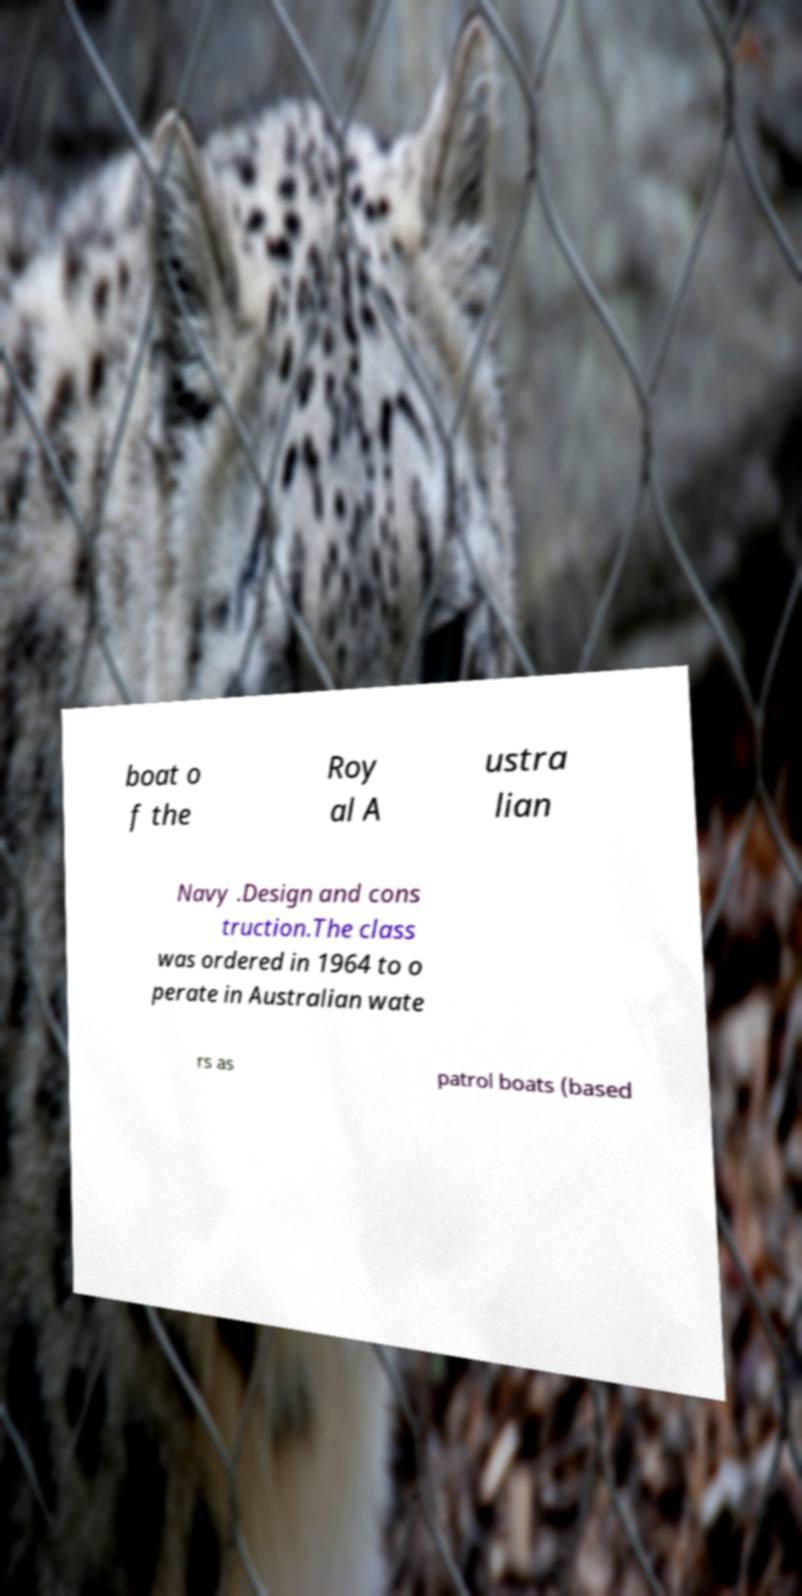I need the written content from this picture converted into text. Can you do that? boat o f the Roy al A ustra lian Navy .Design and cons truction.The class was ordered in 1964 to o perate in Australian wate rs as patrol boats (based 